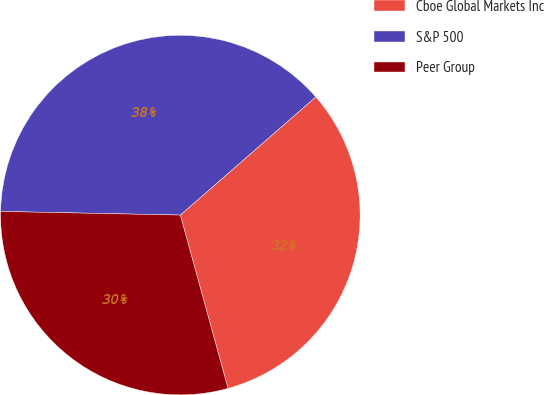Convert chart to OTSL. <chart><loc_0><loc_0><loc_500><loc_500><pie_chart><fcel>Cboe Global Markets Inc<fcel>S&P 500<fcel>Peer Group<nl><fcel>32.14%<fcel>38.26%<fcel>29.6%<nl></chart> 